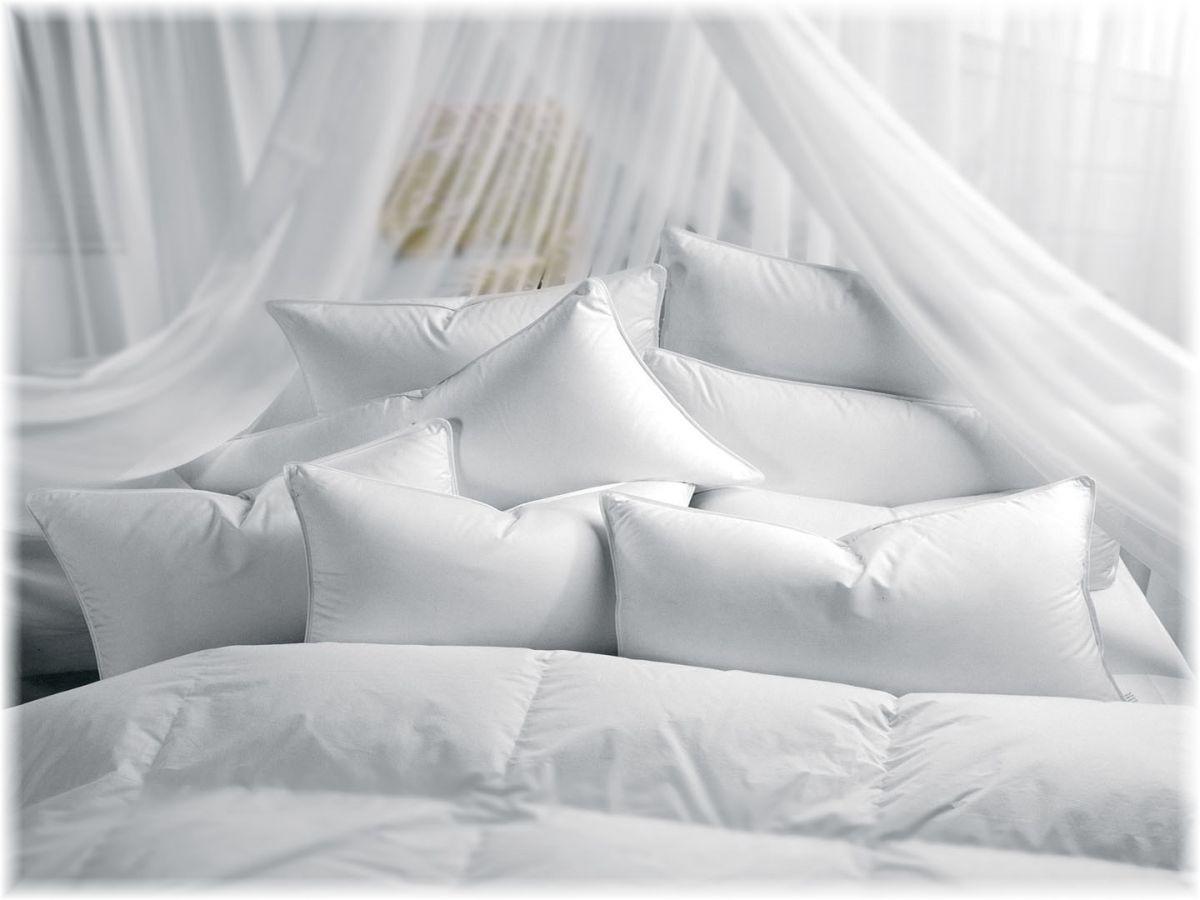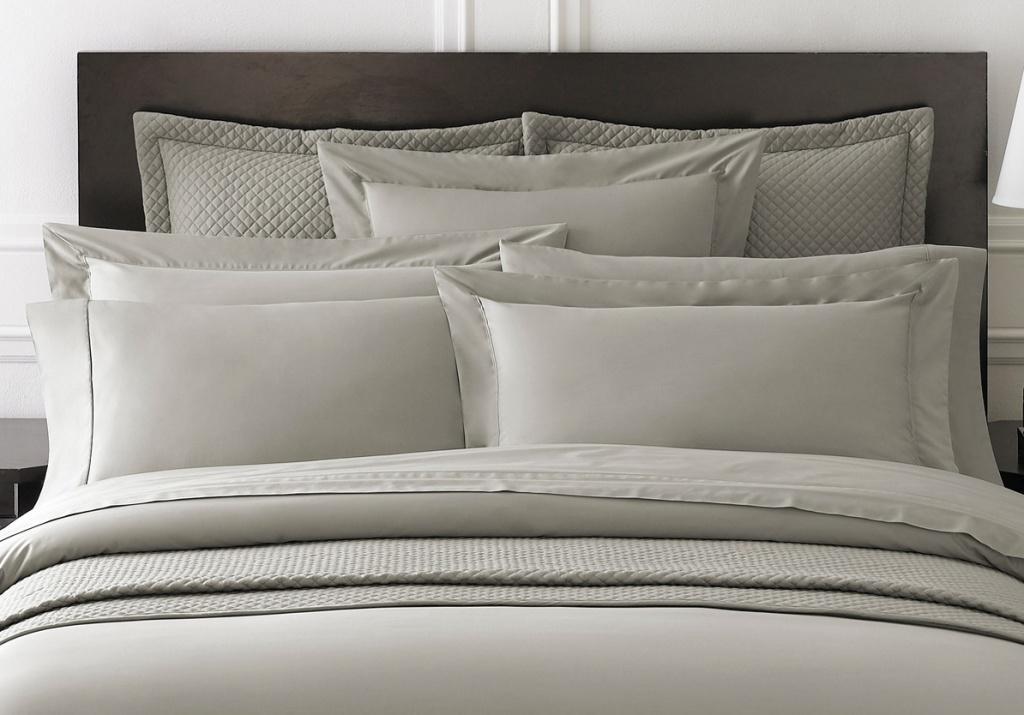The first image is the image on the left, the second image is the image on the right. Analyze the images presented: Is the assertion "There are fewer than seven pillows visible in total." valid? Answer yes or no. No. The first image is the image on the left, the second image is the image on the right. Evaluate the accuracy of this statement regarding the images: "The right image shows at least four pillows on a bed with a brown headboard and white bedding.". Is it true? Answer yes or no. Yes. 